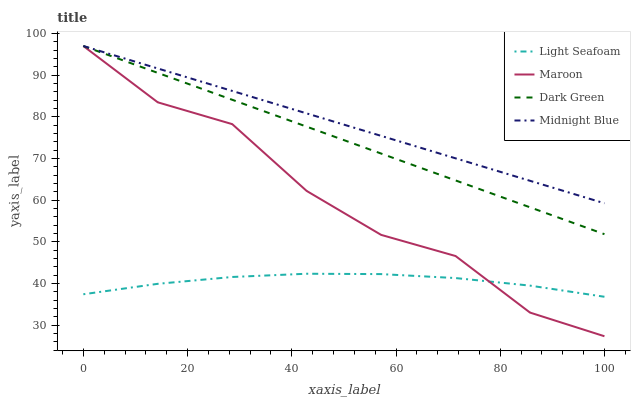Does Light Seafoam have the minimum area under the curve?
Answer yes or no. Yes. Does Midnight Blue have the maximum area under the curve?
Answer yes or no. Yes. Does Maroon have the minimum area under the curve?
Answer yes or no. No. Does Maroon have the maximum area under the curve?
Answer yes or no. No. Is Dark Green the smoothest?
Answer yes or no. Yes. Is Maroon the roughest?
Answer yes or no. Yes. Is Midnight Blue the smoothest?
Answer yes or no. No. Is Midnight Blue the roughest?
Answer yes or no. No. Does Maroon have the lowest value?
Answer yes or no. Yes. Does Midnight Blue have the lowest value?
Answer yes or no. No. Does Dark Green have the highest value?
Answer yes or no. Yes. Is Light Seafoam less than Dark Green?
Answer yes or no. Yes. Is Dark Green greater than Light Seafoam?
Answer yes or no. Yes. Does Midnight Blue intersect Dark Green?
Answer yes or no. Yes. Is Midnight Blue less than Dark Green?
Answer yes or no. No. Is Midnight Blue greater than Dark Green?
Answer yes or no. No. Does Light Seafoam intersect Dark Green?
Answer yes or no. No. 